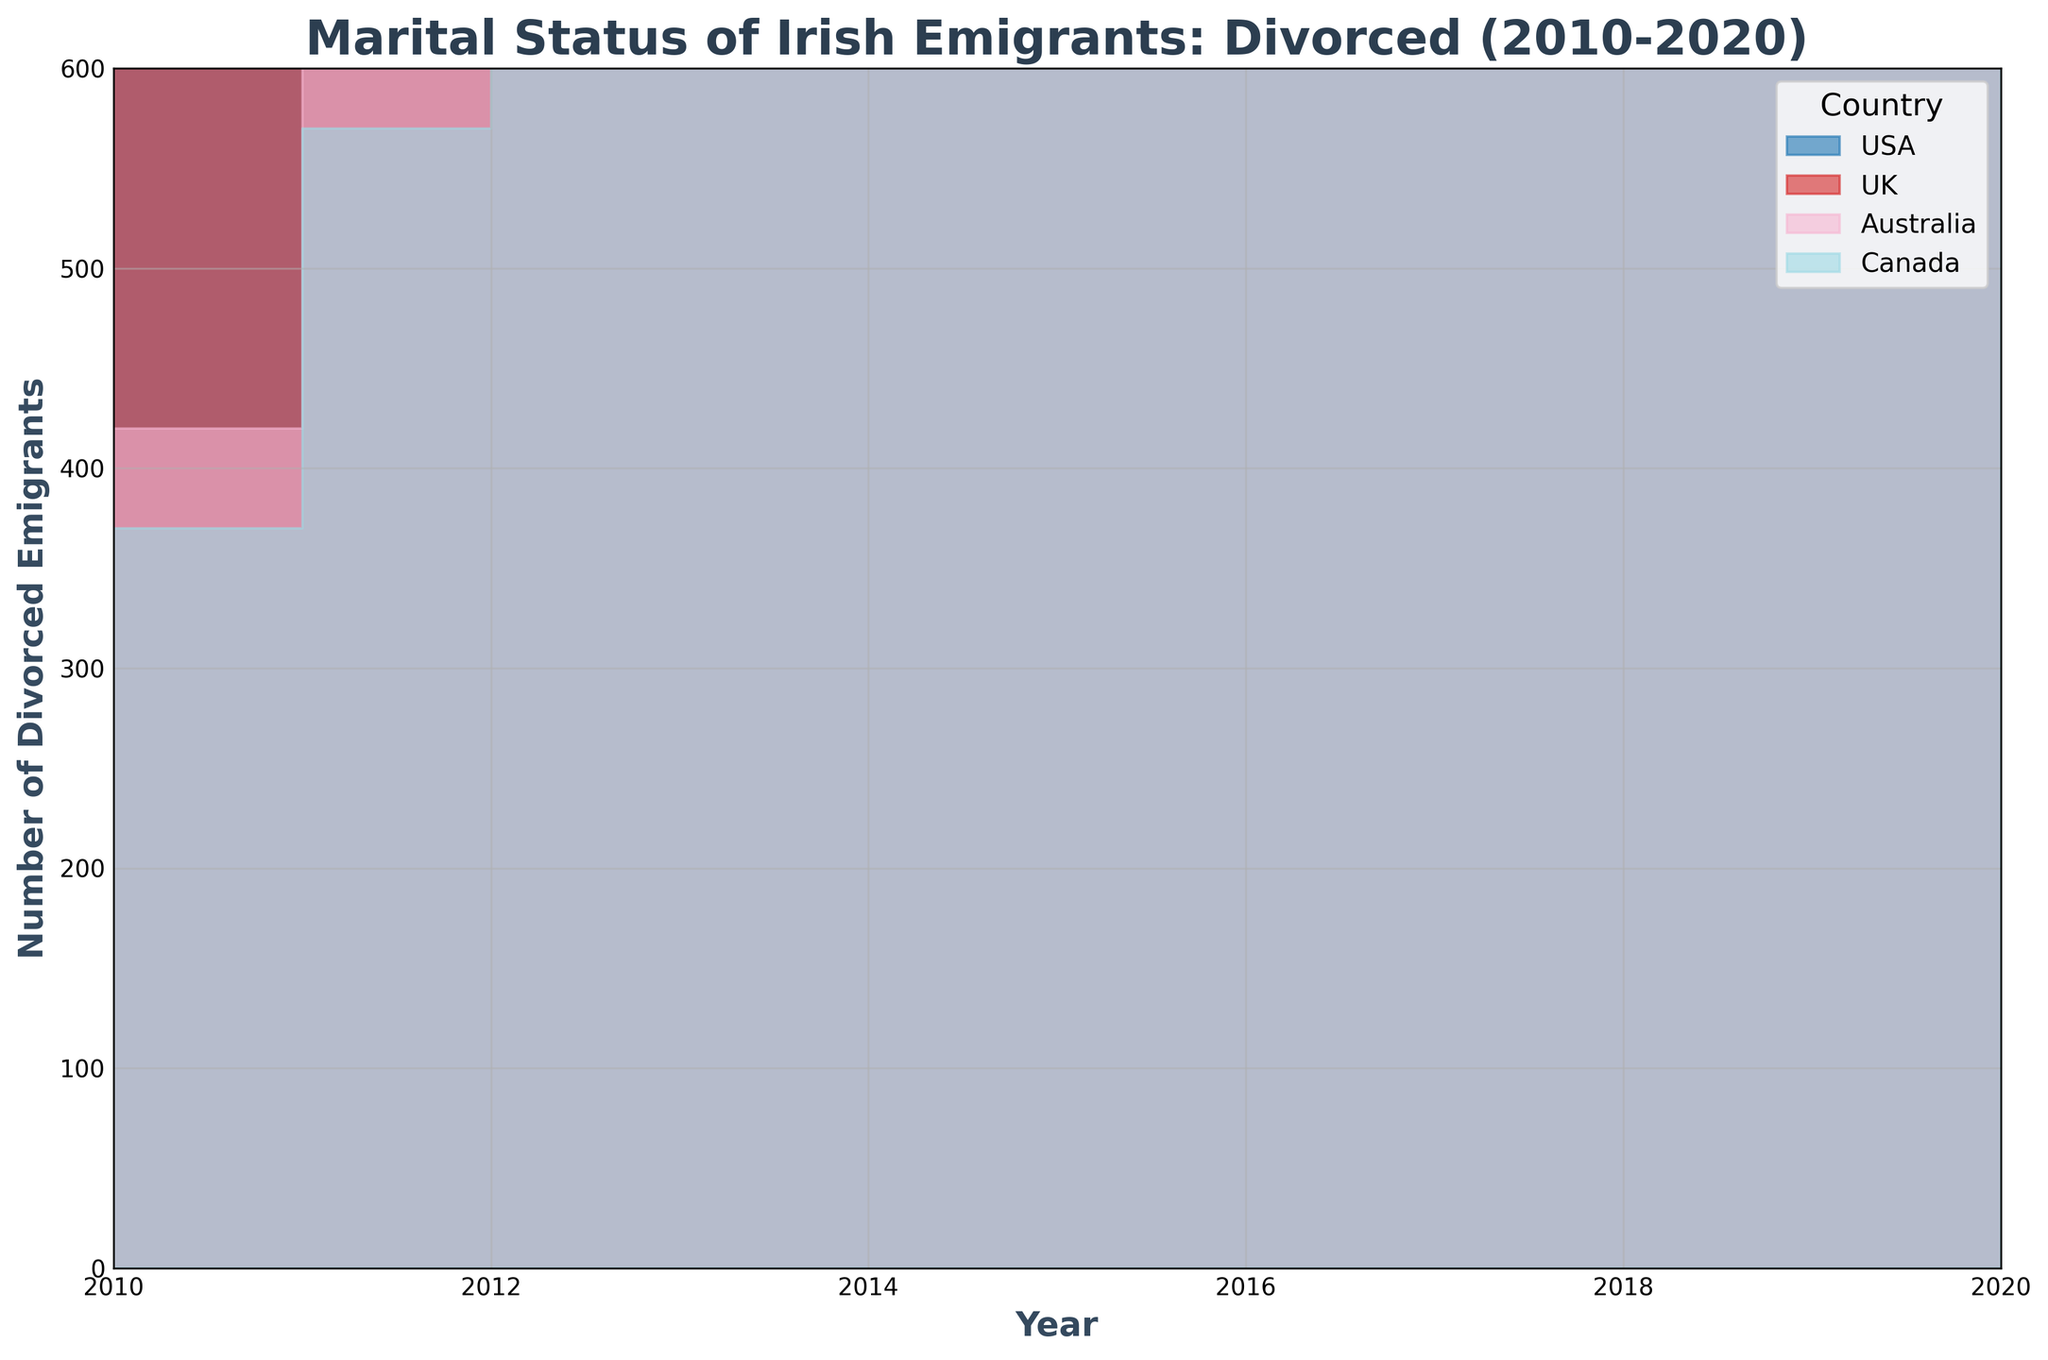What’s the total number of divorced Irish emigrants to the USA from 2010 to 2020 based on the plot? To find the total number of divorced Irish emigrants to the USA from 2010 to 2020, add up all the values depicting the height of the USA segment in each year interval. Summing the values gives you: 300 + 320 + 340 + 360 + 380 + 400 + 420 + 440 + 460 + 480 + 500 = 4400.
Answer: 4400 Which country had the highest number of divorced Irish emigrants in 2010? Look at the height of the segments for each country in 2010. The segment for the UK is the tallest, indicating the highest number of divorced emigrants.
Answer: UK What is the trend of divorced Irish emigrants heading to Australia from 2010 to 2020? Observing the height of the Australian segments over the years, you can see that they are generally increasing. This upward trend shows a rising number of divorced emigrants heading to Australia from 2010 to 2020.
Answer: Increasing Compare the number of divorced Irish emigrants to Canada and Australia in 2015. Which country had more, and by how much? Check the height of the segments for Canada and Australia in 2015. The height for Australia is higher than that of Canada. Subtract Canada's value from Australia's (300 - 230 = 70) to find the difference.
Answer: Australia; 70 more Which year had the highest total number of divorced Irish emigrants across all countries, and what was the total number? To find this, sum up the heights of all segments for each year and identify the year with the highest value. For instance, in 2020 sum up: 500 (USA) + 600 (UK) + 400 (Australia) + 280 (Canada) = 1780. Repeat for all years to find that 2020 has the highest total.
Answer: 2020; 1780 How does the number of divorced Irish emigrants to the UK in 2020 compare to those in the USA in the same year? Look at the height of the segments representing divorced emigrants to the UK and USA in 2020. The UK has 600, and the USA has 500. Therefore, the UK has more by a difference of 100 (600 - 500).
Answer: UK; 100 more What percentage of divorced Irish emigrants went to Canada in 2010 relative to the total number of divorced emigrants that year? Sum the number of divorced emigrants for all countries in 2010 (300 + 400 + 200 + 180 = 1080). Then, find the percentage for Canada: (180/1080) * 100.
Answer: Approximately 16.67% Which country has shown the least variability in the number of divorced Irish emigrants between 2010 and 2020? To determine this, observe which country has the most consistent segment heights across all years. Visually, Canada's segment heights change the least compared to other countries.
Answer: Canada In which year did divorced Irish emigrants to the UK surpass 500? Identify the segments for the UK and find the first year where the height goes above 500. This happens in 2015.
Answer: 2015 What was the combined number of divorced Irish emigrants to both Australia and Canada in 2018? Sum the segments for Australia and Canada in 2018 (360 + 260).
Answer: 620 